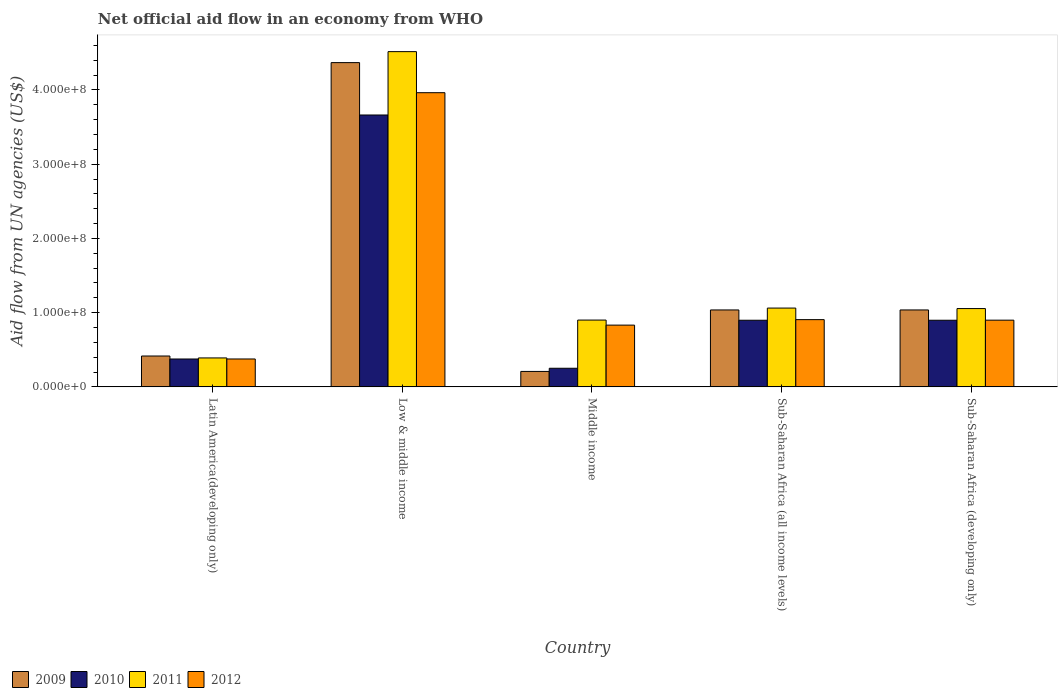How many bars are there on the 3rd tick from the right?
Provide a succinct answer. 4. What is the label of the 4th group of bars from the left?
Provide a short and direct response. Sub-Saharan Africa (all income levels). What is the net official aid flow in 2012 in Sub-Saharan Africa (all income levels)?
Your answer should be very brief. 9.06e+07. Across all countries, what is the maximum net official aid flow in 2011?
Offer a very short reply. 4.52e+08. Across all countries, what is the minimum net official aid flow in 2009?
Ensure brevity in your answer.  2.08e+07. In which country was the net official aid flow in 2009 maximum?
Provide a short and direct response. Low & middle income. In which country was the net official aid flow in 2011 minimum?
Ensure brevity in your answer.  Latin America(developing only). What is the total net official aid flow in 2012 in the graph?
Provide a short and direct response. 6.97e+08. What is the difference between the net official aid flow in 2012 in Middle income and that in Sub-Saharan Africa (all income levels)?
Your response must be concise. -7.39e+06. What is the difference between the net official aid flow in 2010 in Low & middle income and the net official aid flow in 2009 in Sub-Saharan Africa (all income levels)?
Your answer should be compact. 2.63e+08. What is the average net official aid flow in 2009 per country?
Offer a very short reply. 1.41e+08. What is the difference between the net official aid flow of/in 2011 and net official aid flow of/in 2012 in Sub-Saharan Africa (all income levels)?
Make the answer very short. 1.56e+07. In how many countries, is the net official aid flow in 2009 greater than 380000000 US$?
Keep it short and to the point. 1. What is the ratio of the net official aid flow in 2010 in Low & middle income to that in Middle income?
Ensure brevity in your answer.  14.61. Is the net official aid flow in 2012 in Latin America(developing only) less than that in Sub-Saharan Africa (developing only)?
Your response must be concise. Yes. What is the difference between the highest and the second highest net official aid flow in 2011?
Make the answer very short. 3.46e+08. What is the difference between the highest and the lowest net official aid flow in 2011?
Offer a terse response. 4.13e+08. In how many countries, is the net official aid flow in 2012 greater than the average net official aid flow in 2012 taken over all countries?
Your answer should be very brief. 1. Is it the case that in every country, the sum of the net official aid flow in 2012 and net official aid flow in 2010 is greater than the sum of net official aid flow in 2009 and net official aid flow in 2011?
Provide a short and direct response. No. What does the 1st bar from the left in Latin America(developing only) represents?
Offer a terse response. 2009. How many bars are there?
Offer a terse response. 20. Are all the bars in the graph horizontal?
Provide a succinct answer. No. What is the difference between two consecutive major ticks on the Y-axis?
Your answer should be compact. 1.00e+08. Are the values on the major ticks of Y-axis written in scientific E-notation?
Provide a succinct answer. Yes. Does the graph contain any zero values?
Give a very brief answer. No. Does the graph contain grids?
Offer a terse response. No. How many legend labels are there?
Your answer should be compact. 4. How are the legend labels stacked?
Keep it short and to the point. Horizontal. What is the title of the graph?
Your response must be concise. Net official aid flow in an economy from WHO. What is the label or title of the Y-axis?
Keep it short and to the point. Aid flow from UN agencies (US$). What is the Aid flow from UN agencies (US$) of 2009 in Latin America(developing only)?
Make the answer very short. 4.16e+07. What is the Aid flow from UN agencies (US$) of 2010 in Latin America(developing only)?
Ensure brevity in your answer.  3.76e+07. What is the Aid flow from UN agencies (US$) of 2011 in Latin America(developing only)?
Your answer should be very brief. 3.90e+07. What is the Aid flow from UN agencies (US$) in 2012 in Latin America(developing only)?
Keep it short and to the point. 3.76e+07. What is the Aid flow from UN agencies (US$) of 2009 in Low & middle income?
Your response must be concise. 4.37e+08. What is the Aid flow from UN agencies (US$) in 2010 in Low & middle income?
Offer a very short reply. 3.66e+08. What is the Aid flow from UN agencies (US$) of 2011 in Low & middle income?
Give a very brief answer. 4.52e+08. What is the Aid flow from UN agencies (US$) in 2012 in Low & middle income?
Keep it short and to the point. 3.96e+08. What is the Aid flow from UN agencies (US$) in 2009 in Middle income?
Ensure brevity in your answer.  2.08e+07. What is the Aid flow from UN agencies (US$) of 2010 in Middle income?
Provide a short and direct response. 2.51e+07. What is the Aid flow from UN agencies (US$) in 2011 in Middle income?
Offer a terse response. 9.00e+07. What is the Aid flow from UN agencies (US$) in 2012 in Middle income?
Your answer should be compact. 8.32e+07. What is the Aid flow from UN agencies (US$) of 2009 in Sub-Saharan Africa (all income levels)?
Your answer should be very brief. 1.04e+08. What is the Aid flow from UN agencies (US$) of 2010 in Sub-Saharan Africa (all income levels)?
Give a very brief answer. 8.98e+07. What is the Aid flow from UN agencies (US$) in 2011 in Sub-Saharan Africa (all income levels)?
Give a very brief answer. 1.06e+08. What is the Aid flow from UN agencies (US$) in 2012 in Sub-Saharan Africa (all income levels)?
Your response must be concise. 9.06e+07. What is the Aid flow from UN agencies (US$) in 2009 in Sub-Saharan Africa (developing only)?
Your answer should be very brief. 1.04e+08. What is the Aid flow from UN agencies (US$) of 2010 in Sub-Saharan Africa (developing only)?
Make the answer very short. 8.98e+07. What is the Aid flow from UN agencies (US$) in 2011 in Sub-Saharan Africa (developing only)?
Your answer should be compact. 1.05e+08. What is the Aid flow from UN agencies (US$) of 2012 in Sub-Saharan Africa (developing only)?
Provide a succinct answer. 8.98e+07. Across all countries, what is the maximum Aid flow from UN agencies (US$) of 2009?
Keep it short and to the point. 4.37e+08. Across all countries, what is the maximum Aid flow from UN agencies (US$) of 2010?
Keep it short and to the point. 3.66e+08. Across all countries, what is the maximum Aid flow from UN agencies (US$) in 2011?
Your answer should be very brief. 4.52e+08. Across all countries, what is the maximum Aid flow from UN agencies (US$) of 2012?
Provide a short and direct response. 3.96e+08. Across all countries, what is the minimum Aid flow from UN agencies (US$) of 2009?
Give a very brief answer. 2.08e+07. Across all countries, what is the minimum Aid flow from UN agencies (US$) in 2010?
Your answer should be very brief. 2.51e+07. Across all countries, what is the minimum Aid flow from UN agencies (US$) in 2011?
Provide a short and direct response. 3.90e+07. Across all countries, what is the minimum Aid flow from UN agencies (US$) in 2012?
Your answer should be compact. 3.76e+07. What is the total Aid flow from UN agencies (US$) in 2009 in the graph?
Keep it short and to the point. 7.06e+08. What is the total Aid flow from UN agencies (US$) in 2010 in the graph?
Keep it short and to the point. 6.08e+08. What is the total Aid flow from UN agencies (US$) in 2011 in the graph?
Make the answer very short. 7.92e+08. What is the total Aid flow from UN agencies (US$) in 2012 in the graph?
Your answer should be very brief. 6.97e+08. What is the difference between the Aid flow from UN agencies (US$) in 2009 in Latin America(developing only) and that in Low & middle income?
Provide a succinct answer. -3.95e+08. What is the difference between the Aid flow from UN agencies (US$) of 2010 in Latin America(developing only) and that in Low & middle income?
Provide a short and direct response. -3.29e+08. What is the difference between the Aid flow from UN agencies (US$) of 2011 in Latin America(developing only) and that in Low & middle income?
Provide a short and direct response. -4.13e+08. What is the difference between the Aid flow from UN agencies (US$) of 2012 in Latin America(developing only) and that in Low & middle income?
Your response must be concise. -3.59e+08. What is the difference between the Aid flow from UN agencies (US$) of 2009 in Latin America(developing only) and that in Middle income?
Provide a short and direct response. 2.08e+07. What is the difference between the Aid flow from UN agencies (US$) of 2010 in Latin America(developing only) and that in Middle income?
Make the answer very short. 1.25e+07. What is the difference between the Aid flow from UN agencies (US$) of 2011 in Latin America(developing only) and that in Middle income?
Keep it short and to the point. -5.10e+07. What is the difference between the Aid flow from UN agencies (US$) of 2012 in Latin America(developing only) and that in Middle income?
Give a very brief answer. -4.56e+07. What is the difference between the Aid flow from UN agencies (US$) in 2009 in Latin America(developing only) and that in Sub-Saharan Africa (all income levels)?
Provide a succinct answer. -6.20e+07. What is the difference between the Aid flow from UN agencies (US$) of 2010 in Latin America(developing only) and that in Sub-Saharan Africa (all income levels)?
Provide a short and direct response. -5.22e+07. What is the difference between the Aid flow from UN agencies (US$) of 2011 in Latin America(developing only) and that in Sub-Saharan Africa (all income levels)?
Your response must be concise. -6.72e+07. What is the difference between the Aid flow from UN agencies (US$) of 2012 in Latin America(developing only) and that in Sub-Saharan Africa (all income levels)?
Your answer should be compact. -5.30e+07. What is the difference between the Aid flow from UN agencies (US$) in 2009 in Latin America(developing only) and that in Sub-Saharan Africa (developing only)?
Keep it short and to the point. -6.20e+07. What is the difference between the Aid flow from UN agencies (US$) of 2010 in Latin America(developing only) and that in Sub-Saharan Africa (developing only)?
Offer a terse response. -5.22e+07. What is the difference between the Aid flow from UN agencies (US$) of 2011 in Latin America(developing only) and that in Sub-Saharan Africa (developing only)?
Provide a short and direct response. -6.65e+07. What is the difference between the Aid flow from UN agencies (US$) of 2012 in Latin America(developing only) and that in Sub-Saharan Africa (developing only)?
Ensure brevity in your answer.  -5.23e+07. What is the difference between the Aid flow from UN agencies (US$) in 2009 in Low & middle income and that in Middle income?
Your answer should be compact. 4.16e+08. What is the difference between the Aid flow from UN agencies (US$) in 2010 in Low & middle income and that in Middle income?
Provide a short and direct response. 3.41e+08. What is the difference between the Aid flow from UN agencies (US$) of 2011 in Low & middle income and that in Middle income?
Your answer should be compact. 3.62e+08. What is the difference between the Aid flow from UN agencies (US$) of 2012 in Low & middle income and that in Middle income?
Ensure brevity in your answer.  3.13e+08. What is the difference between the Aid flow from UN agencies (US$) of 2009 in Low & middle income and that in Sub-Saharan Africa (all income levels)?
Ensure brevity in your answer.  3.33e+08. What is the difference between the Aid flow from UN agencies (US$) of 2010 in Low & middle income and that in Sub-Saharan Africa (all income levels)?
Give a very brief answer. 2.76e+08. What is the difference between the Aid flow from UN agencies (US$) of 2011 in Low & middle income and that in Sub-Saharan Africa (all income levels)?
Your response must be concise. 3.45e+08. What is the difference between the Aid flow from UN agencies (US$) of 2012 in Low & middle income and that in Sub-Saharan Africa (all income levels)?
Ensure brevity in your answer.  3.06e+08. What is the difference between the Aid flow from UN agencies (US$) in 2009 in Low & middle income and that in Sub-Saharan Africa (developing only)?
Offer a very short reply. 3.33e+08. What is the difference between the Aid flow from UN agencies (US$) in 2010 in Low & middle income and that in Sub-Saharan Africa (developing only)?
Keep it short and to the point. 2.76e+08. What is the difference between the Aid flow from UN agencies (US$) of 2011 in Low & middle income and that in Sub-Saharan Africa (developing only)?
Keep it short and to the point. 3.46e+08. What is the difference between the Aid flow from UN agencies (US$) of 2012 in Low & middle income and that in Sub-Saharan Africa (developing only)?
Keep it short and to the point. 3.06e+08. What is the difference between the Aid flow from UN agencies (US$) in 2009 in Middle income and that in Sub-Saharan Africa (all income levels)?
Your response must be concise. -8.28e+07. What is the difference between the Aid flow from UN agencies (US$) of 2010 in Middle income and that in Sub-Saharan Africa (all income levels)?
Give a very brief answer. -6.47e+07. What is the difference between the Aid flow from UN agencies (US$) in 2011 in Middle income and that in Sub-Saharan Africa (all income levels)?
Offer a terse response. -1.62e+07. What is the difference between the Aid flow from UN agencies (US$) in 2012 in Middle income and that in Sub-Saharan Africa (all income levels)?
Ensure brevity in your answer.  -7.39e+06. What is the difference between the Aid flow from UN agencies (US$) in 2009 in Middle income and that in Sub-Saharan Africa (developing only)?
Your answer should be compact. -8.28e+07. What is the difference between the Aid flow from UN agencies (US$) of 2010 in Middle income and that in Sub-Saharan Africa (developing only)?
Your answer should be compact. -6.47e+07. What is the difference between the Aid flow from UN agencies (US$) in 2011 in Middle income and that in Sub-Saharan Africa (developing only)?
Your answer should be compact. -1.55e+07. What is the difference between the Aid flow from UN agencies (US$) of 2012 in Middle income and that in Sub-Saharan Africa (developing only)?
Your answer should be very brief. -6.67e+06. What is the difference between the Aid flow from UN agencies (US$) of 2009 in Sub-Saharan Africa (all income levels) and that in Sub-Saharan Africa (developing only)?
Provide a succinct answer. 0. What is the difference between the Aid flow from UN agencies (US$) of 2011 in Sub-Saharan Africa (all income levels) and that in Sub-Saharan Africa (developing only)?
Keep it short and to the point. 6.70e+05. What is the difference between the Aid flow from UN agencies (US$) of 2012 in Sub-Saharan Africa (all income levels) and that in Sub-Saharan Africa (developing only)?
Offer a terse response. 7.20e+05. What is the difference between the Aid flow from UN agencies (US$) in 2009 in Latin America(developing only) and the Aid flow from UN agencies (US$) in 2010 in Low & middle income?
Make the answer very short. -3.25e+08. What is the difference between the Aid flow from UN agencies (US$) in 2009 in Latin America(developing only) and the Aid flow from UN agencies (US$) in 2011 in Low & middle income?
Keep it short and to the point. -4.10e+08. What is the difference between the Aid flow from UN agencies (US$) in 2009 in Latin America(developing only) and the Aid flow from UN agencies (US$) in 2012 in Low & middle income?
Provide a short and direct response. -3.55e+08. What is the difference between the Aid flow from UN agencies (US$) of 2010 in Latin America(developing only) and the Aid flow from UN agencies (US$) of 2011 in Low & middle income?
Make the answer very short. -4.14e+08. What is the difference between the Aid flow from UN agencies (US$) in 2010 in Latin America(developing only) and the Aid flow from UN agencies (US$) in 2012 in Low & middle income?
Your response must be concise. -3.59e+08. What is the difference between the Aid flow from UN agencies (US$) of 2011 in Latin America(developing only) and the Aid flow from UN agencies (US$) of 2012 in Low & middle income?
Offer a very short reply. -3.57e+08. What is the difference between the Aid flow from UN agencies (US$) in 2009 in Latin America(developing only) and the Aid flow from UN agencies (US$) in 2010 in Middle income?
Your response must be concise. 1.65e+07. What is the difference between the Aid flow from UN agencies (US$) of 2009 in Latin America(developing only) and the Aid flow from UN agencies (US$) of 2011 in Middle income?
Make the answer very short. -4.84e+07. What is the difference between the Aid flow from UN agencies (US$) of 2009 in Latin America(developing only) and the Aid flow from UN agencies (US$) of 2012 in Middle income?
Your answer should be compact. -4.16e+07. What is the difference between the Aid flow from UN agencies (US$) in 2010 in Latin America(developing only) and the Aid flow from UN agencies (US$) in 2011 in Middle income?
Offer a terse response. -5.24e+07. What is the difference between the Aid flow from UN agencies (US$) of 2010 in Latin America(developing only) and the Aid flow from UN agencies (US$) of 2012 in Middle income?
Make the answer very short. -4.56e+07. What is the difference between the Aid flow from UN agencies (US$) of 2011 in Latin America(developing only) and the Aid flow from UN agencies (US$) of 2012 in Middle income?
Your answer should be very brief. -4.42e+07. What is the difference between the Aid flow from UN agencies (US$) of 2009 in Latin America(developing only) and the Aid flow from UN agencies (US$) of 2010 in Sub-Saharan Africa (all income levels)?
Give a very brief answer. -4.82e+07. What is the difference between the Aid flow from UN agencies (US$) in 2009 in Latin America(developing only) and the Aid flow from UN agencies (US$) in 2011 in Sub-Saharan Africa (all income levels)?
Ensure brevity in your answer.  -6.46e+07. What is the difference between the Aid flow from UN agencies (US$) of 2009 in Latin America(developing only) and the Aid flow from UN agencies (US$) of 2012 in Sub-Saharan Africa (all income levels)?
Make the answer very short. -4.90e+07. What is the difference between the Aid flow from UN agencies (US$) in 2010 in Latin America(developing only) and the Aid flow from UN agencies (US$) in 2011 in Sub-Saharan Africa (all income levels)?
Ensure brevity in your answer.  -6.86e+07. What is the difference between the Aid flow from UN agencies (US$) of 2010 in Latin America(developing only) and the Aid flow from UN agencies (US$) of 2012 in Sub-Saharan Africa (all income levels)?
Make the answer very short. -5.30e+07. What is the difference between the Aid flow from UN agencies (US$) in 2011 in Latin America(developing only) and the Aid flow from UN agencies (US$) in 2012 in Sub-Saharan Africa (all income levels)?
Ensure brevity in your answer.  -5.16e+07. What is the difference between the Aid flow from UN agencies (US$) in 2009 in Latin America(developing only) and the Aid flow from UN agencies (US$) in 2010 in Sub-Saharan Africa (developing only)?
Your response must be concise. -4.82e+07. What is the difference between the Aid flow from UN agencies (US$) in 2009 in Latin America(developing only) and the Aid flow from UN agencies (US$) in 2011 in Sub-Saharan Africa (developing only)?
Provide a succinct answer. -6.39e+07. What is the difference between the Aid flow from UN agencies (US$) in 2009 in Latin America(developing only) and the Aid flow from UN agencies (US$) in 2012 in Sub-Saharan Africa (developing only)?
Your response must be concise. -4.83e+07. What is the difference between the Aid flow from UN agencies (US$) in 2010 in Latin America(developing only) and the Aid flow from UN agencies (US$) in 2011 in Sub-Saharan Africa (developing only)?
Ensure brevity in your answer.  -6.79e+07. What is the difference between the Aid flow from UN agencies (US$) in 2010 in Latin America(developing only) and the Aid flow from UN agencies (US$) in 2012 in Sub-Saharan Africa (developing only)?
Make the answer very short. -5.23e+07. What is the difference between the Aid flow from UN agencies (US$) of 2011 in Latin America(developing only) and the Aid flow from UN agencies (US$) of 2012 in Sub-Saharan Africa (developing only)?
Give a very brief answer. -5.09e+07. What is the difference between the Aid flow from UN agencies (US$) of 2009 in Low & middle income and the Aid flow from UN agencies (US$) of 2010 in Middle income?
Provide a short and direct response. 4.12e+08. What is the difference between the Aid flow from UN agencies (US$) in 2009 in Low & middle income and the Aid flow from UN agencies (US$) in 2011 in Middle income?
Keep it short and to the point. 3.47e+08. What is the difference between the Aid flow from UN agencies (US$) in 2009 in Low & middle income and the Aid flow from UN agencies (US$) in 2012 in Middle income?
Offer a terse response. 3.54e+08. What is the difference between the Aid flow from UN agencies (US$) in 2010 in Low & middle income and the Aid flow from UN agencies (US$) in 2011 in Middle income?
Your response must be concise. 2.76e+08. What is the difference between the Aid flow from UN agencies (US$) in 2010 in Low & middle income and the Aid flow from UN agencies (US$) in 2012 in Middle income?
Your answer should be very brief. 2.83e+08. What is the difference between the Aid flow from UN agencies (US$) of 2011 in Low & middle income and the Aid flow from UN agencies (US$) of 2012 in Middle income?
Make the answer very short. 3.68e+08. What is the difference between the Aid flow from UN agencies (US$) of 2009 in Low & middle income and the Aid flow from UN agencies (US$) of 2010 in Sub-Saharan Africa (all income levels)?
Provide a short and direct response. 3.47e+08. What is the difference between the Aid flow from UN agencies (US$) of 2009 in Low & middle income and the Aid flow from UN agencies (US$) of 2011 in Sub-Saharan Africa (all income levels)?
Keep it short and to the point. 3.31e+08. What is the difference between the Aid flow from UN agencies (US$) in 2009 in Low & middle income and the Aid flow from UN agencies (US$) in 2012 in Sub-Saharan Africa (all income levels)?
Provide a short and direct response. 3.46e+08. What is the difference between the Aid flow from UN agencies (US$) in 2010 in Low & middle income and the Aid flow from UN agencies (US$) in 2011 in Sub-Saharan Africa (all income levels)?
Keep it short and to the point. 2.60e+08. What is the difference between the Aid flow from UN agencies (US$) of 2010 in Low & middle income and the Aid flow from UN agencies (US$) of 2012 in Sub-Saharan Africa (all income levels)?
Provide a succinct answer. 2.76e+08. What is the difference between the Aid flow from UN agencies (US$) in 2011 in Low & middle income and the Aid flow from UN agencies (US$) in 2012 in Sub-Saharan Africa (all income levels)?
Make the answer very short. 3.61e+08. What is the difference between the Aid flow from UN agencies (US$) in 2009 in Low & middle income and the Aid flow from UN agencies (US$) in 2010 in Sub-Saharan Africa (developing only)?
Offer a very short reply. 3.47e+08. What is the difference between the Aid flow from UN agencies (US$) of 2009 in Low & middle income and the Aid flow from UN agencies (US$) of 2011 in Sub-Saharan Africa (developing only)?
Keep it short and to the point. 3.31e+08. What is the difference between the Aid flow from UN agencies (US$) of 2009 in Low & middle income and the Aid flow from UN agencies (US$) of 2012 in Sub-Saharan Africa (developing only)?
Provide a succinct answer. 3.47e+08. What is the difference between the Aid flow from UN agencies (US$) in 2010 in Low & middle income and the Aid flow from UN agencies (US$) in 2011 in Sub-Saharan Africa (developing only)?
Keep it short and to the point. 2.61e+08. What is the difference between the Aid flow from UN agencies (US$) in 2010 in Low & middle income and the Aid flow from UN agencies (US$) in 2012 in Sub-Saharan Africa (developing only)?
Your response must be concise. 2.76e+08. What is the difference between the Aid flow from UN agencies (US$) in 2011 in Low & middle income and the Aid flow from UN agencies (US$) in 2012 in Sub-Saharan Africa (developing only)?
Make the answer very short. 3.62e+08. What is the difference between the Aid flow from UN agencies (US$) in 2009 in Middle income and the Aid flow from UN agencies (US$) in 2010 in Sub-Saharan Africa (all income levels)?
Provide a succinct answer. -6.90e+07. What is the difference between the Aid flow from UN agencies (US$) in 2009 in Middle income and the Aid flow from UN agencies (US$) in 2011 in Sub-Saharan Africa (all income levels)?
Give a very brief answer. -8.54e+07. What is the difference between the Aid flow from UN agencies (US$) of 2009 in Middle income and the Aid flow from UN agencies (US$) of 2012 in Sub-Saharan Africa (all income levels)?
Offer a very short reply. -6.98e+07. What is the difference between the Aid flow from UN agencies (US$) of 2010 in Middle income and the Aid flow from UN agencies (US$) of 2011 in Sub-Saharan Africa (all income levels)?
Offer a very short reply. -8.11e+07. What is the difference between the Aid flow from UN agencies (US$) of 2010 in Middle income and the Aid flow from UN agencies (US$) of 2012 in Sub-Saharan Africa (all income levels)?
Your response must be concise. -6.55e+07. What is the difference between the Aid flow from UN agencies (US$) in 2011 in Middle income and the Aid flow from UN agencies (US$) in 2012 in Sub-Saharan Africa (all income levels)?
Keep it short and to the point. -5.90e+05. What is the difference between the Aid flow from UN agencies (US$) in 2009 in Middle income and the Aid flow from UN agencies (US$) in 2010 in Sub-Saharan Africa (developing only)?
Your answer should be very brief. -6.90e+07. What is the difference between the Aid flow from UN agencies (US$) of 2009 in Middle income and the Aid flow from UN agencies (US$) of 2011 in Sub-Saharan Africa (developing only)?
Provide a short and direct response. -8.47e+07. What is the difference between the Aid flow from UN agencies (US$) of 2009 in Middle income and the Aid flow from UN agencies (US$) of 2012 in Sub-Saharan Africa (developing only)?
Make the answer very short. -6.90e+07. What is the difference between the Aid flow from UN agencies (US$) of 2010 in Middle income and the Aid flow from UN agencies (US$) of 2011 in Sub-Saharan Africa (developing only)?
Keep it short and to the point. -8.04e+07. What is the difference between the Aid flow from UN agencies (US$) of 2010 in Middle income and the Aid flow from UN agencies (US$) of 2012 in Sub-Saharan Africa (developing only)?
Your response must be concise. -6.48e+07. What is the difference between the Aid flow from UN agencies (US$) of 2011 in Middle income and the Aid flow from UN agencies (US$) of 2012 in Sub-Saharan Africa (developing only)?
Give a very brief answer. 1.30e+05. What is the difference between the Aid flow from UN agencies (US$) of 2009 in Sub-Saharan Africa (all income levels) and the Aid flow from UN agencies (US$) of 2010 in Sub-Saharan Africa (developing only)?
Provide a succinct answer. 1.39e+07. What is the difference between the Aid flow from UN agencies (US$) in 2009 in Sub-Saharan Africa (all income levels) and the Aid flow from UN agencies (US$) in 2011 in Sub-Saharan Africa (developing only)?
Provide a succinct answer. -1.86e+06. What is the difference between the Aid flow from UN agencies (US$) in 2009 in Sub-Saharan Africa (all income levels) and the Aid flow from UN agencies (US$) in 2012 in Sub-Saharan Africa (developing only)?
Your response must be concise. 1.38e+07. What is the difference between the Aid flow from UN agencies (US$) of 2010 in Sub-Saharan Africa (all income levels) and the Aid flow from UN agencies (US$) of 2011 in Sub-Saharan Africa (developing only)?
Offer a very short reply. -1.57e+07. What is the difference between the Aid flow from UN agencies (US$) in 2010 in Sub-Saharan Africa (all income levels) and the Aid flow from UN agencies (US$) in 2012 in Sub-Saharan Africa (developing only)?
Offer a very short reply. -9.00e+04. What is the difference between the Aid flow from UN agencies (US$) of 2011 in Sub-Saharan Africa (all income levels) and the Aid flow from UN agencies (US$) of 2012 in Sub-Saharan Africa (developing only)?
Offer a very short reply. 1.63e+07. What is the average Aid flow from UN agencies (US$) in 2009 per country?
Offer a terse response. 1.41e+08. What is the average Aid flow from UN agencies (US$) of 2010 per country?
Give a very brief answer. 1.22e+08. What is the average Aid flow from UN agencies (US$) of 2011 per country?
Offer a very short reply. 1.58e+08. What is the average Aid flow from UN agencies (US$) in 2012 per country?
Keep it short and to the point. 1.39e+08. What is the difference between the Aid flow from UN agencies (US$) of 2009 and Aid flow from UN agencies (US$) of 2010 in Latin America(developing only)?
Your answer should be compact. 4.01e+06. What is the difference between the Aid flow from UN agencies (US$) of 2009 and Aid flow from UN agencies (US$) of 2011 in Latin America(developing only)?
Offer a terse response. 2.59e+06. What is the difference between the Aid flow from UN agencies (US$) in 2009 and Aid flow from UN agencies (US$) in 2012 in Latin America(developing only)?
Your answer should be very brief. 3.99e+06. What is the difference between the Aid flow from UN agencies (US$) of 2010 and Aid flow from UN agencies (US$) of 2011 in Latin America(developing only)?
Provide a succinct answer. -1.42e+06. What is the difference between the Aid flow from UN agencies (US$) of 2011 and Aid flow from UN agencies (US$) of 2012 in Latin America(developing only)?
Provide a succinct answer. 1.40e+06. What is the difference between the Aid flow from UN agencies (US$) in 2009 and Aid flow from UN agencies (US$) in 2010 in Low & middle income?
Provide a succinct answer. 7.06e+07. What is the difference between the Aid flow from UN agencies (US$) of 2009 and Aid flow from UN agencies (US$) of 2011 in Low & middle income?
Your response must be concise. -1.48e+07. What is the difference between the Aid flow from UN agencies (US$) in 2009 and Aid flow from UN agencies (US$) in 2012 in Low & middle income?
Provide a short and direct response. 4.05e+07. What is the difference between the Aid flow from UN agencies (US$) of 2010 and Aid flow from UN agencies (US$) of 2011 in Low & middle income?
Make the answer very short. -8.54e+07. What is the difference between the Aid flow from UN agencies (US$) of 2010 and Aid flow from UN agencies (US$) of 2012 in Low & middle income?
Provide a succinct answer. -3.00e+07. What is the difference between the Aid flow from UN agencies (US$) of 2011 and Aid flow from UN agencies (US$) of 2012 in Low & middle income?
Provide a short and direct response. 5.53e+07. What is the difference between the Aid flow from UN agencies (US$) in 2009 and Aid flow from UN agencies (US$) in 2010 in Middle income?
Your response must be concise. -4.27e+06. What is the difference between the Aid flow from UN agencies (US$) of 2009 and Aid flow from UN agencies (US$) of 2011 in Middle income?
Your answer should be very brief. -6.92e+07. What is the difference between the Aid flow from UN agencies (US$) in 2009 and Aid flow from UN agencies (US$) in 2012 in Middle income?
Provide a short and direct response. -6.24e+07. What is the difference between the Aid flow from UN agencies (US$) in 2010 and Aid flow from UN agencies (US$) in 2011 in Middle income?
Ensure brevity in your answer.  -6.49e+07. What is the difference between the Aid flow from UN agencies (US$) in 2010 and Aid flow from UN agencies (US$) in 2012 in Middle income?
Provide a short and direct response. -5.81e+07. What is the difference between the Aid flow from UN agencies (US$) of 2011 and Aid flow from UN agencies (US$) of 2012 in Middle income?
Give a very brief answer. 6.80e+06. What is the difference between the Aid flow from UN agencies (US$) of 2009 and Aid flow from UN agencies (US$) of 2010 in Sub-Saharan Africa (all income levels)?
Keep it short and to the point. 1.39e+07. What is the difference between the Aid flow from UN agencies (US$) of 2009 and Aid flow from UN agencies (US$) of 2011 in Sub-Saharan Africa (all income levels)?
Your answer should be compact. -2.53e+06. What is the difference between the Aid flow from UN agencies (US$) of 2009 and Aid flow from UN agencies (US$) of 2012 in Sub-Saharan Africa (all income levels)?
Keep it short and to the point. 1.30e+07. What is the difference between the Aid flow from UN agencies (US$) of 2010 and Aid flow from UN agencies (US$) of 2011 in Sub-Saharan Africa (all income levels)?
Ensure brevity in your answer.  -1.64e+07. What is the difference between the Aid flow from UN agencies (US$) in 2010 and Aid flow from UN agencies (US$) in 2012 in Sub-Saharan Africa (all income levels)?
Your answer should be very brief. -8.10e+05. What is the difference between the Aid flow from UN agencies (US$) in 2011 and Aid flow from UN agencies (US$) in 2012 in Sub-Saharan Africa (all income levels)?
Provide a succinct answer. 1.56e+07. What is the difference between the Aid flow from UN agencies (US$) in 2009 and Aid flow from UN agencies (US$) in 2010 in Sub-Saharan Africa (developing only)?
Your answer should be compact. 1.39e+07. What is the difference between the Aid flow from UN agencies (US$) in 2009 and Aid flow from UN agencies (US$) in 2011 in Sub-Saharan Africa (developing only)?
Make the answer very short. -1.86e+06. What is the difference between the Aid flow from UN agencies (US$) of 2009 and Aid flow from UN agencies (US$) of 2012 in Sub-Saharan Africa (developing only)?
Provide a succinct answer. 1.38e+07. What is the difference between the Aid flow from UN agencies (US$) of 2010 and Aid flow from UN agencies (US$) of 2011 in Sub-Saharan Africa (developing only)?
Keep it short and to the point. -1.57e+07. What is the difference between the Aid flow from UN agencies (US$) of 2011 and Aid flow from UN agencies (US$) of 2012 in Sub-Saharan Africa (developing only)?
Make the answer very short. 1.56e+07. What is the ratio of the Aid flow from UN agencies (US$) of 2009 in Latin America(developing only) to that in Low & middle income?
Offer a terse response. 0.1. What is the ratio of the Aid flow from UN agencies (US$) of 2010 in Latin America(developing only) to that in Low & middle income?
Keep it short and to the point. 0.1. What is the ratio of the Aid flow from UN agencies (US$) in 2011 in Latin America(developing only) to that in Low & middle income?
Make the answer very short. 0.09. What is the ratio of the Aid flow from UN agencies (US$) of 2012 in Latin America(developing only) to that in Low & middle income?
Your answer should be very brief. 0.09. What is the ratio of the Aid flow from UN agencies (US$) of 2009 in Latin America(developing only) to that in Middle income?
Give a very brief answer. 2. What is the ratio of the Aid flow from UN agencies (US$) in 2010 in Latin America(developing only) to that in Middle income?
Give a very brief answer. 1.5. What is the ratio of the Aid flow from UN agencies (US$) of 2011 in Latin America(developing only) to that in Middle income?
Offer a terse response. 0.43. What is the ratio of the Aid flow from UN agencies (US$) of 2012 in Latin America(developing only) to that in Middle income?
Keep it short and to the point. 0.45. What is the ratio of the Aid flow from UN agencies (US$) in 2009 in Latin America(developing only) to that in Sub-Saharan Africa (all income levels)?
Keep it short and to the point. 0.4. What is the ratio of the Aid flow from UN agencies (US$) in 2010 in Latin America(developing only) to that in Sub-Saharan Africa (all income levels)?
Keep it short and to the point. 0.42. What is the ratio of the Aid flow from UN agencies (US$) in 2011 in Latin America(developing only) to that in Sub-Saharan Africa (all income levels)?
Provide a succinct answer. 0.37. What is the ratio of the Aid flow from UN agencies (US$) of 2012 in Latin America(developing only) to that in Sub-Saharan Africa (all income levels)?
Offer a very short reply. 0.41. What is the ratio of the Aid flow from UN agencies (US$) of 2009 in Latin America(developing only) to that in Sub-Saharan Africa (developing only)?
Make the answer very short. 0.4. What is the ratio of the Aid flow from UN agencies (US$) of 2010 in Latin America(developing only) to that in Sub-Saharan Africa (developing only)?
Make the answer very short. 0.42. What is the ratio of the Aid flow from UN agencies (US$) of 2011 in Latin America(developing only) to that in Sub-Saharan Africa (developing only)?
Offer a terse response. 0.37. What is the ratio of the Aid flow from UN agencies (US$) in 2012 in Latin America(developing only) to that in Sub-Saharan Africa (developing only)?
Provide a succinct answer. 0.42. What is the ratio of the Aid flow from UN agencies (US$) in 2009 in Low & middle income to that in Middle income?
Your answer should be compact. 21. What is the ratio of the Aid flow from UN agencies (US$) in 2010 in Low & middle income to that in Middle income?
Keep it short and to the point. 14.61. What is the ratio of the Aid flow from UN agencies (US$) of 2011 in Low & middle income to that in Middle income?
Provide a short and direct response. 5.02. What is the ratio of the Aid flow from UN agencies (US$) in 2012 in Low & middle income to that in Middle income?
Keep it short and to the point. 4.76. What is the ratio of the Aid flow from UN agencies (US$) of 2009 in Low & middle income to that in Sub-Saharan Africa (all income levels)?
Your response must be concise. 4.22. What is the ratio of the Aid flow from UN agencies (US$) of 2010 in Low & middle income to that in Sub-Saharan Africa (all income levels)?
Your response must be concise. 4.08. What is the ratio of the Aid flow from UN agencies (US$) in 2011 in Low & middle income to that in Sub-Saharan Africa (all income levels)?
Ensure brevity in your answer.  4.25. What is the ratio of the Aid flow from UN agencies (US$) of 2012 in Low & middle income to that in Sub-Saharan Africa (all income levels)?
Give a very brief answer. 4.38. What is the ratio of the Aid flow from UN agencies (US$) in 2009 in Low & middle income to that in Sub-Saharan Africa (developing only)?
Give a very brief answer. 4.22. What is the ratio of the Aid flow from UN agencies (US$) of 2010 in Low & middle income to that in Sub-Saharan Africa (developing only)?
Ensure brevity in your answer.  4.08. What is the ratio of the Aid flow from UN agencies (US$) in 2011 in Low & middle income to that in Sub-Saharan Africa (developing only)?
Keep it short and to the point. 4.28. What is the ratio of the Aid flow from UN agencies (US$) in 2012 in Low & middle income to that in Sub-Saharan Africa (developing only)?
Ensure brevity in your answer.  4.41. What is the ratio of the Aid flow from UN agencies (US$) in 2009 in Middle income to that in Sub-Saharan Africa (all income levels)?
Offer a very short reply. 0.2. What is the ratio of the Aid flow from UN agencies (US$) of 2010 in Middle income to that in Sub-Saharan Africa (all income levels)?
Offer a terse response. 0.28. What is the ratio of the Aid flow from UN agencies (US$) of 2011 in Middle income to that in Sub-Saharan Africa (all income levels)?
Your response must be concise. 0.85. What is the ratio of the Aid flow from UN agencies (US$) of 2012 in Middle income to that in Sub-Saharan Africa (all income levels)?
Make the answer very short. 0.92. What is the ratio of the Aid flow from UN agencies (US$) in 2009 in Middle income to that in Sub-Saharan Africa (developing only)?
Provide a short and direct response. 0.2. What is the ratio of the Aid flow from UN agencies (US$) in 2010 in Middle income to that in Sub-Saharan Africa (developing only)?
Give a very brief answer. 0.28. What is the ratio of the Aid flow from UN agencies (US$) in 2011 in Middle income to that in Sub-Saharan Africa (developing only)?
Keep it short and to the point. 0.85. What is the ratio of the Aid flow from UN agencies (US$) in 2012 in Middle income to that in Sub-Saharan Africa (developing only)?
Keep it short and to the point. 0.93. What is the ratio of the Aid flow from UN agencies (US$) of 2011 in Sub-Saharan Africa (all income levels) to that in Sub-Saharan Africa (developing only)?
Ensure brevity in your answer.  1.01. What is the ratio of the Aid flow from UN agencies (US$) in 2012 in Sub-Saharan Africa (all income levels) to that in Sub-Saharan Africa (developing only)?
Your answer should be very brief. 1.01. What is the difference between the highest and the second highest Aid flow from UN agencies (US$) in 2009?
Provide a succinct answer. 3.33e+08. What is the difference between the highest and the second highest Aid flow from UN agencies (US$) of 2010?
Keep it short and to the point. 2.76e+08. What is the difference between the highest and the second highest Aid flow from UN agencies (US$) of 2011?
Give a very brief answer. 3.45e+08. What is the difference between the highest and the second highest Aid flow from UN agencies (US$) of 2012?
Offer a very short reply. 3.06e+08. What is the difference between the highest and the lowest Aid flow from UN agencies (US$) of 2009?
Keep it short and to the point. 4.16e+08. What is the difference between the highest and the lowest Aid flow from UN agencies (US$) in 2010?
Provide a succinct answer. 3.41e+08. What is the difference between the highest and the lowest Aid flow from UN agencies (US$) in 2011?
Provide a succinct answer. 4.13e+08. What is the difference between the highest and the lowest Aid flow from UN agencies (US$) of 2012?
Keep it short and to the point. 3.59e+08. 